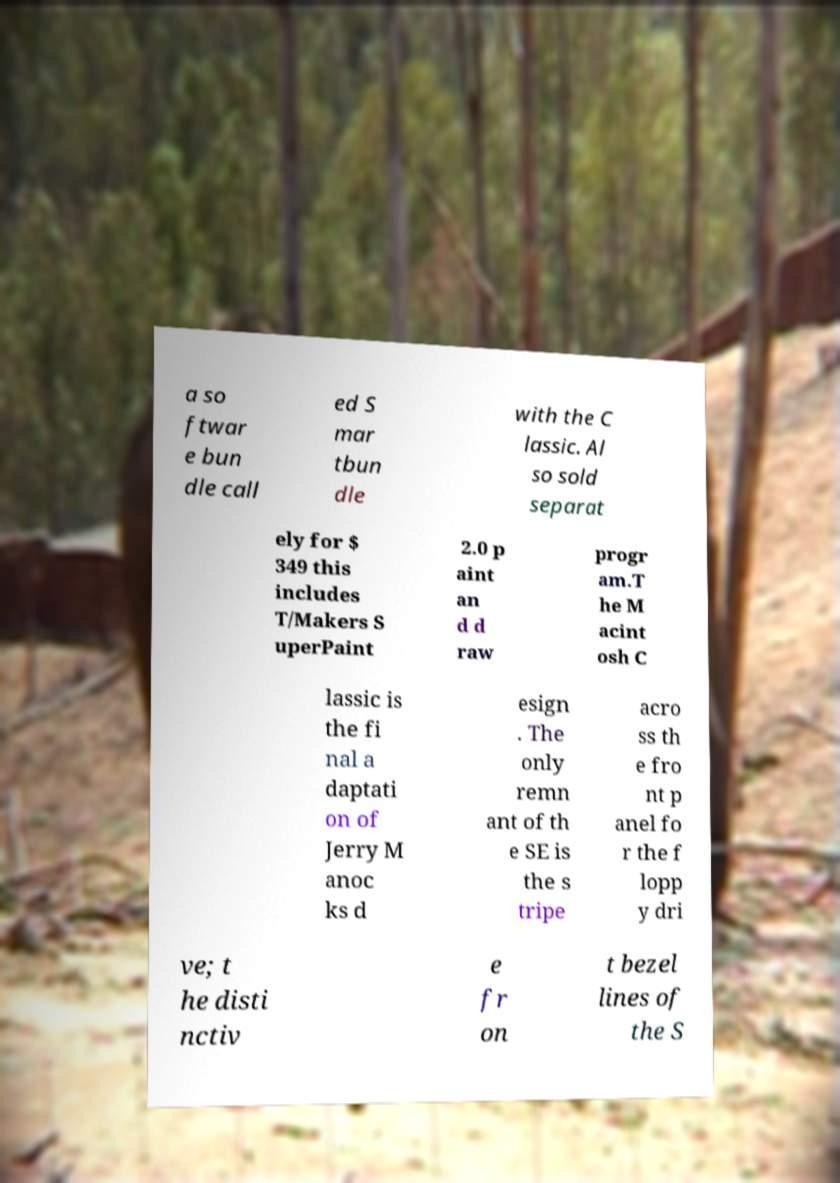Could you assist in decoding the text presented in this image and type it out clearly? a so ftwar e bun dle call ed S mar tbun dle with the C lassic. Al so sold separat ely for $ 349 this includes T/Makers S uperPaint 2.0 p aint an d d raw progr am.T he M acint osh C lassic is the fi nal a daptati on of Jerry M anoc ks d esign . The only remn ant of th e SE is the s tripe acro ss th e fro nt p anel fo r the f lopp y dri ve; t he disti nctiv e fr on t bezel lines of the S 